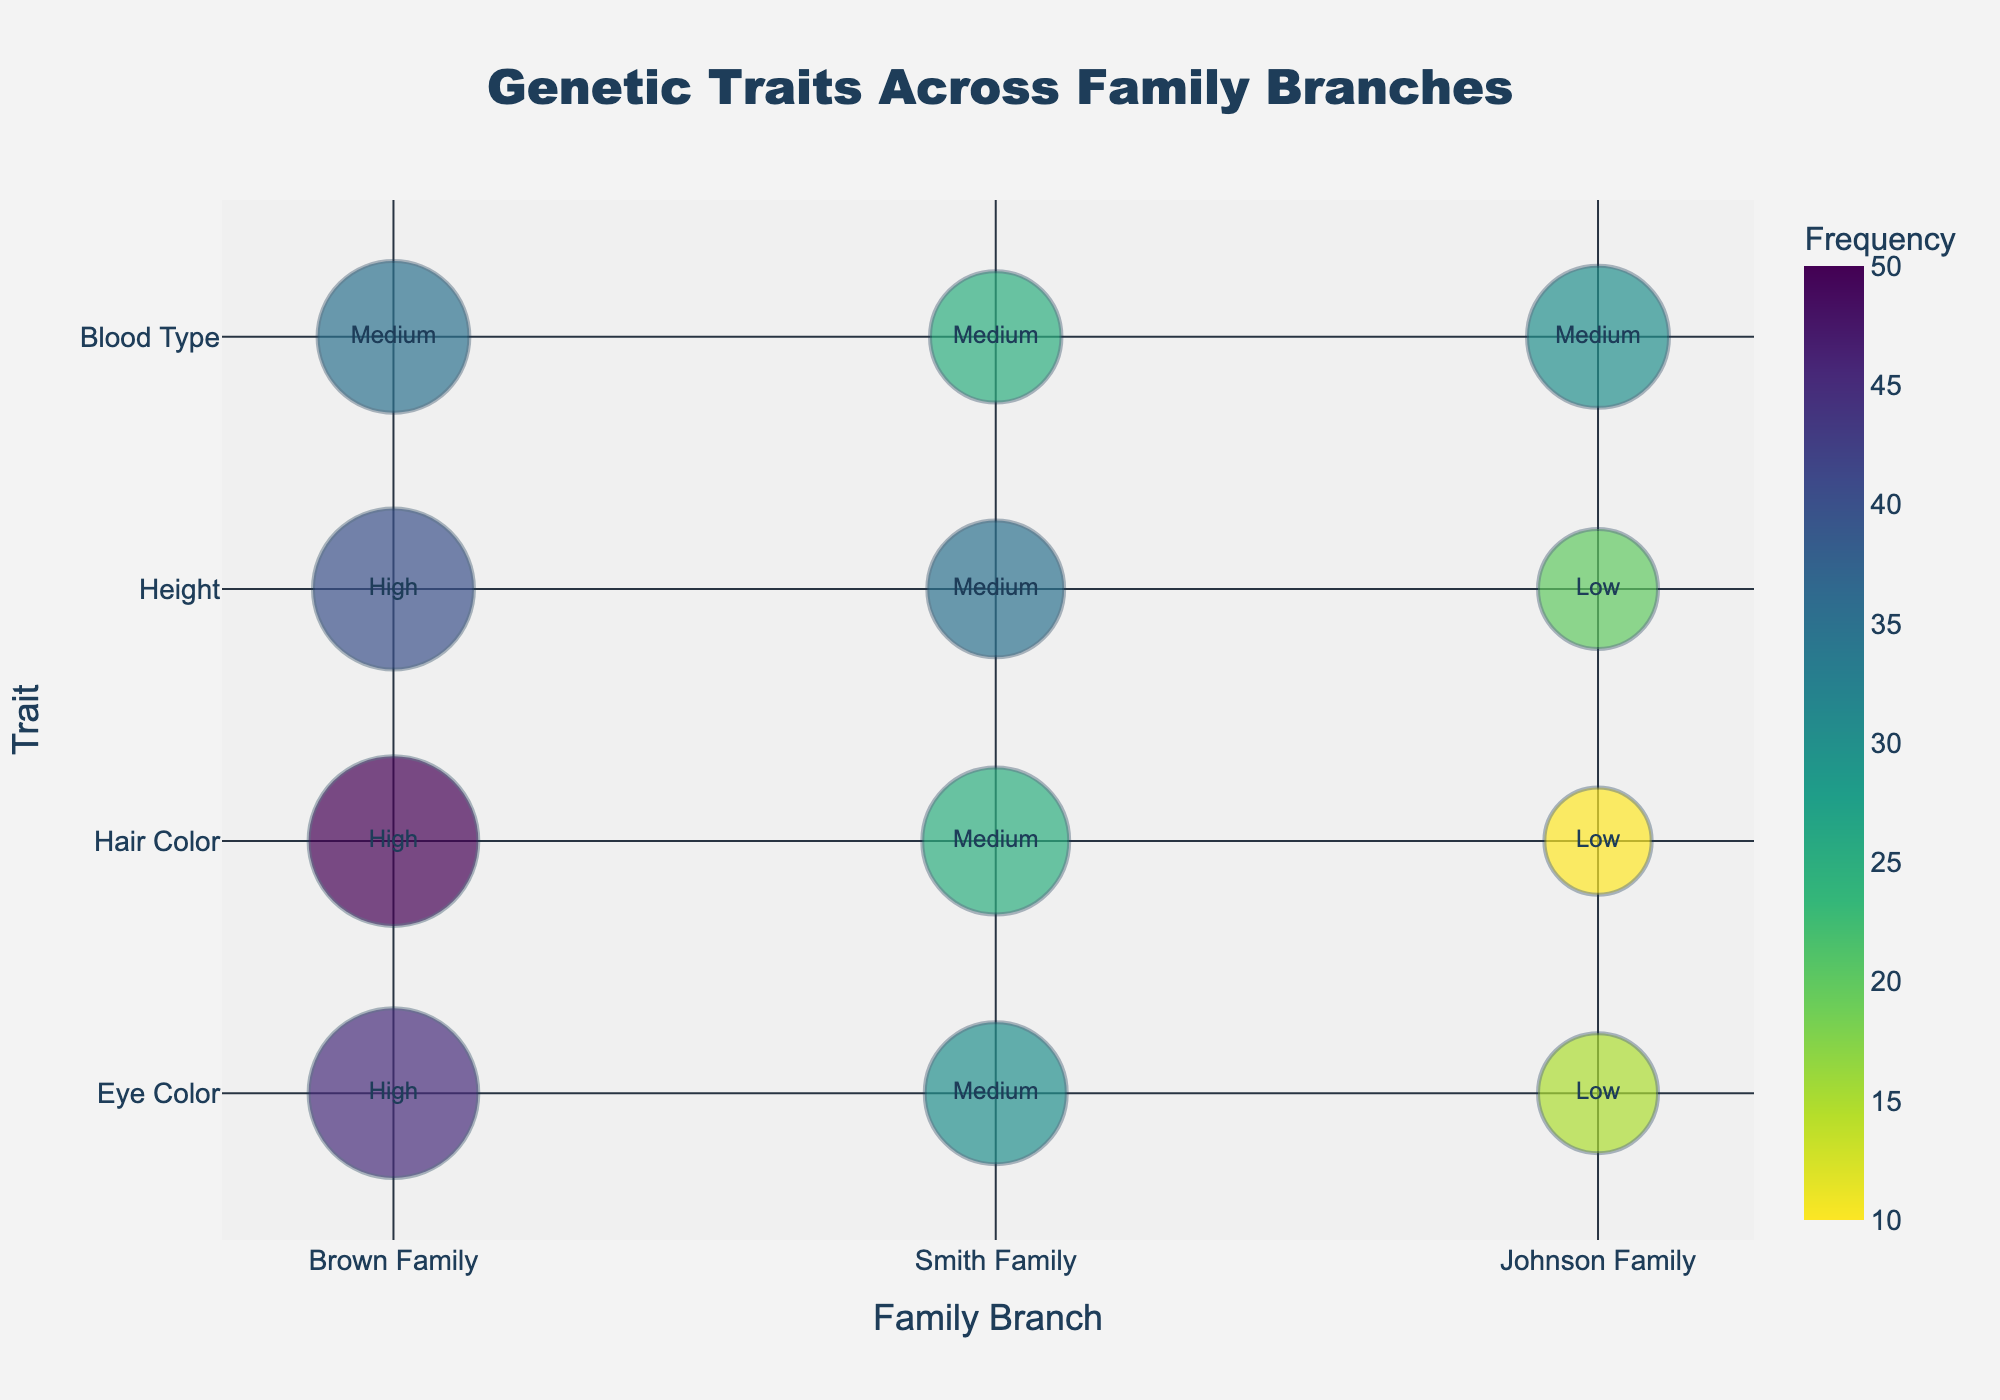What's the title of the figure? Look at the top of the figure where the title is usually placed. The title reads "Genetic Traits Across Family Branches".
Answer: Genetic Traits Across Family Branches How many different traits are displayed in the figure? Count the distinct traits listed on the vertical axis. The traits are Eye Color, Hair Color, Height, and Blood Type.
Answer: 4 Which family branch has the highest frequency for Eye Color? For the Eye Color trait, look for the largest bubble on the horizontal axis. The Brown Family has the largest bubble, indicating the highest frequency.
Answer: Brown Family This The height of the bubble displays the frequency of each trait. When comparing Hair Color across family branches, look at the height of each bubble. The Brown Family has the largest bubble followed by Smith Family, with the Johnson Family having the smallest bubble.
Answer: Brown Family > Smith Family > Johnson Family Which trait has the highest impact level in the Smith Family? Look at the bubbles corresponding to the Smith Family for each trait and read the text within the bubbles. Eye Color and Hair Color both have an impact level of "Medium."
Answer: Eye Color and Hair Color How does the frequency of Height in the Johnson Family compare to that in the Smith Family? Locate the bubbles for Height within each family branch. The Johnson Family has a frequency of 20 while the Smith Family has a frequency of 35, meaning the frequency is higher in the Smith Family.
Answer: Higher in Smith Family What is the total frequency of Blood Type across all family branches? Look at the frequency values for Blood Type in each family branch and sum them up: 35 (Brown Family) + 25 (Smith Family) + 30 (Johnson Family) = 90
Answer: 90 What is the average frequency of traits in the Brown Family? Sum the frequency values for each trait in the Brown Family and divide by the number of traits: (45 + 50 + 40 + 35) / 4 = 170 / 4 = 42.5
Answer: 42.5 